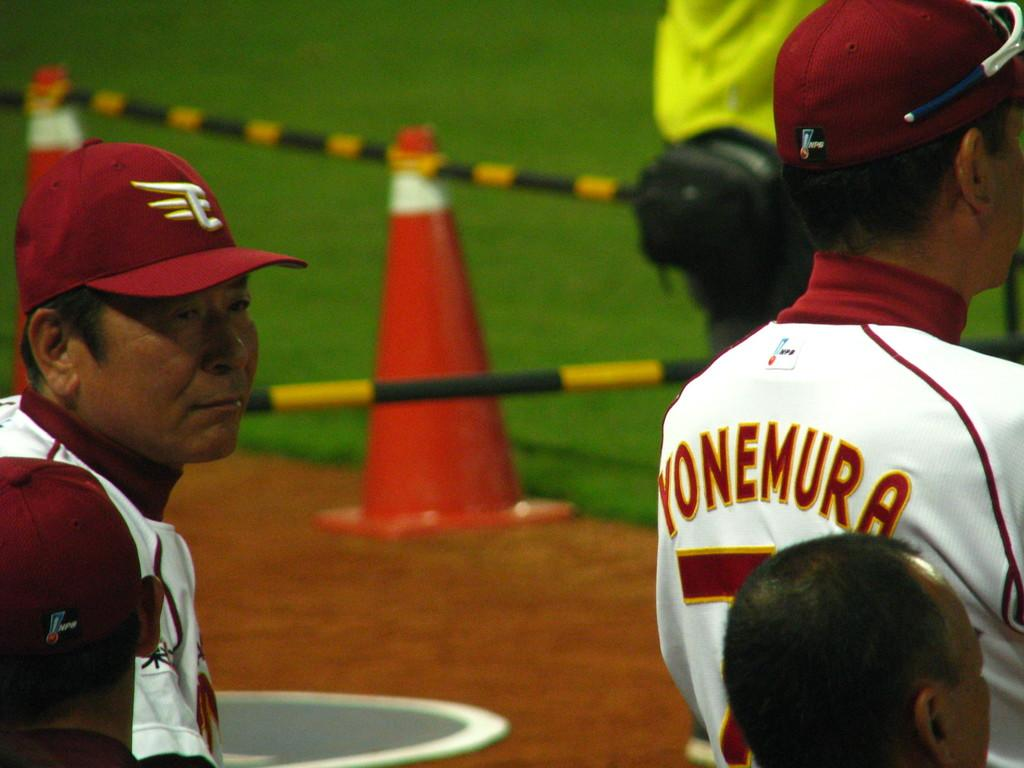How many people are in the image? There are people in the image. What can be seen on the heads of two persons in the front? Two persons in the front are wearing caps. What type of vegetation is visible in the background of the image? There is grass in the background of the image. What objects can be seen in the image that resemble long, thin sticks? There are two rods in the image. What safety object is present in the image? There is a traffic cone in the image. What type of trade is being conducted in the image? There is no indication of any trade being conducted in the image. What box can be seen in the image? There is no box present in the image. 